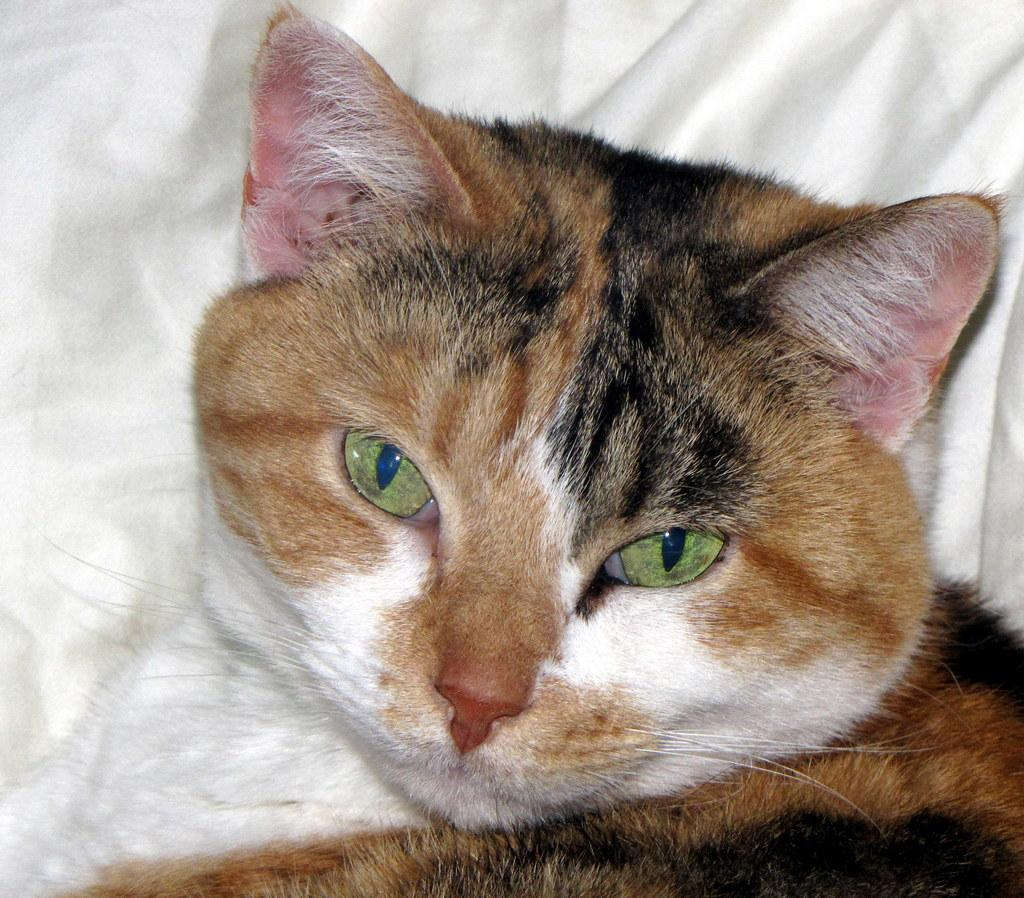What type of animal is in the picture? There is a cat in the picture. What color is the cat? The cat is brown in color. What is the size of the cat in the picture? The size of the cat cannot be determined from the image alone, as there is no reference point for comparison. 